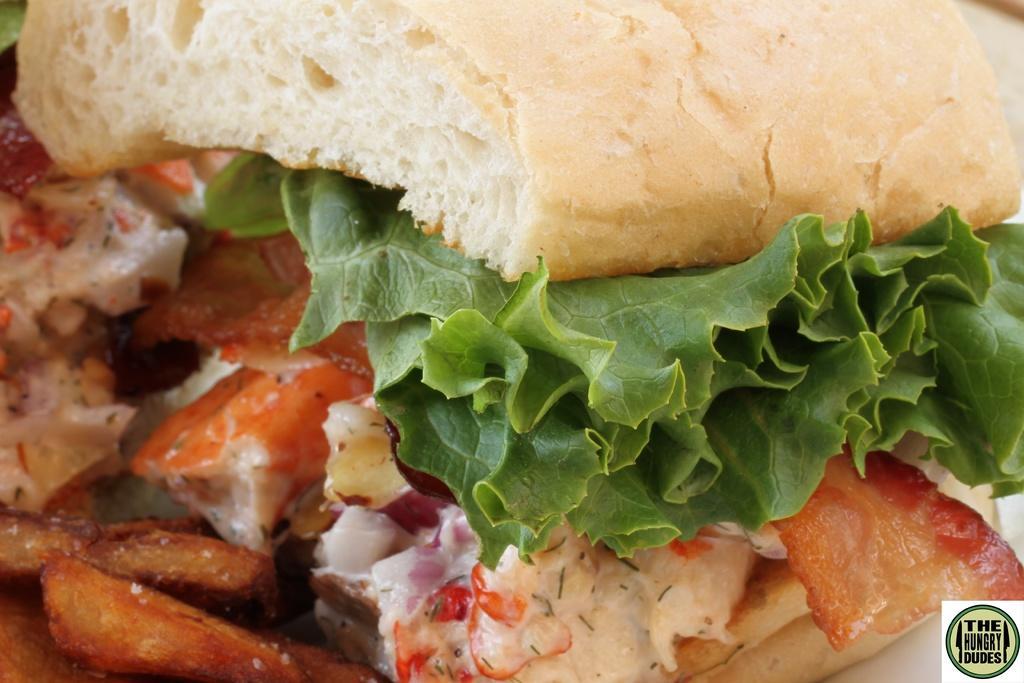Could you give a brief overview of what you see in this image? In this image we can see a burger on the white color plate. 